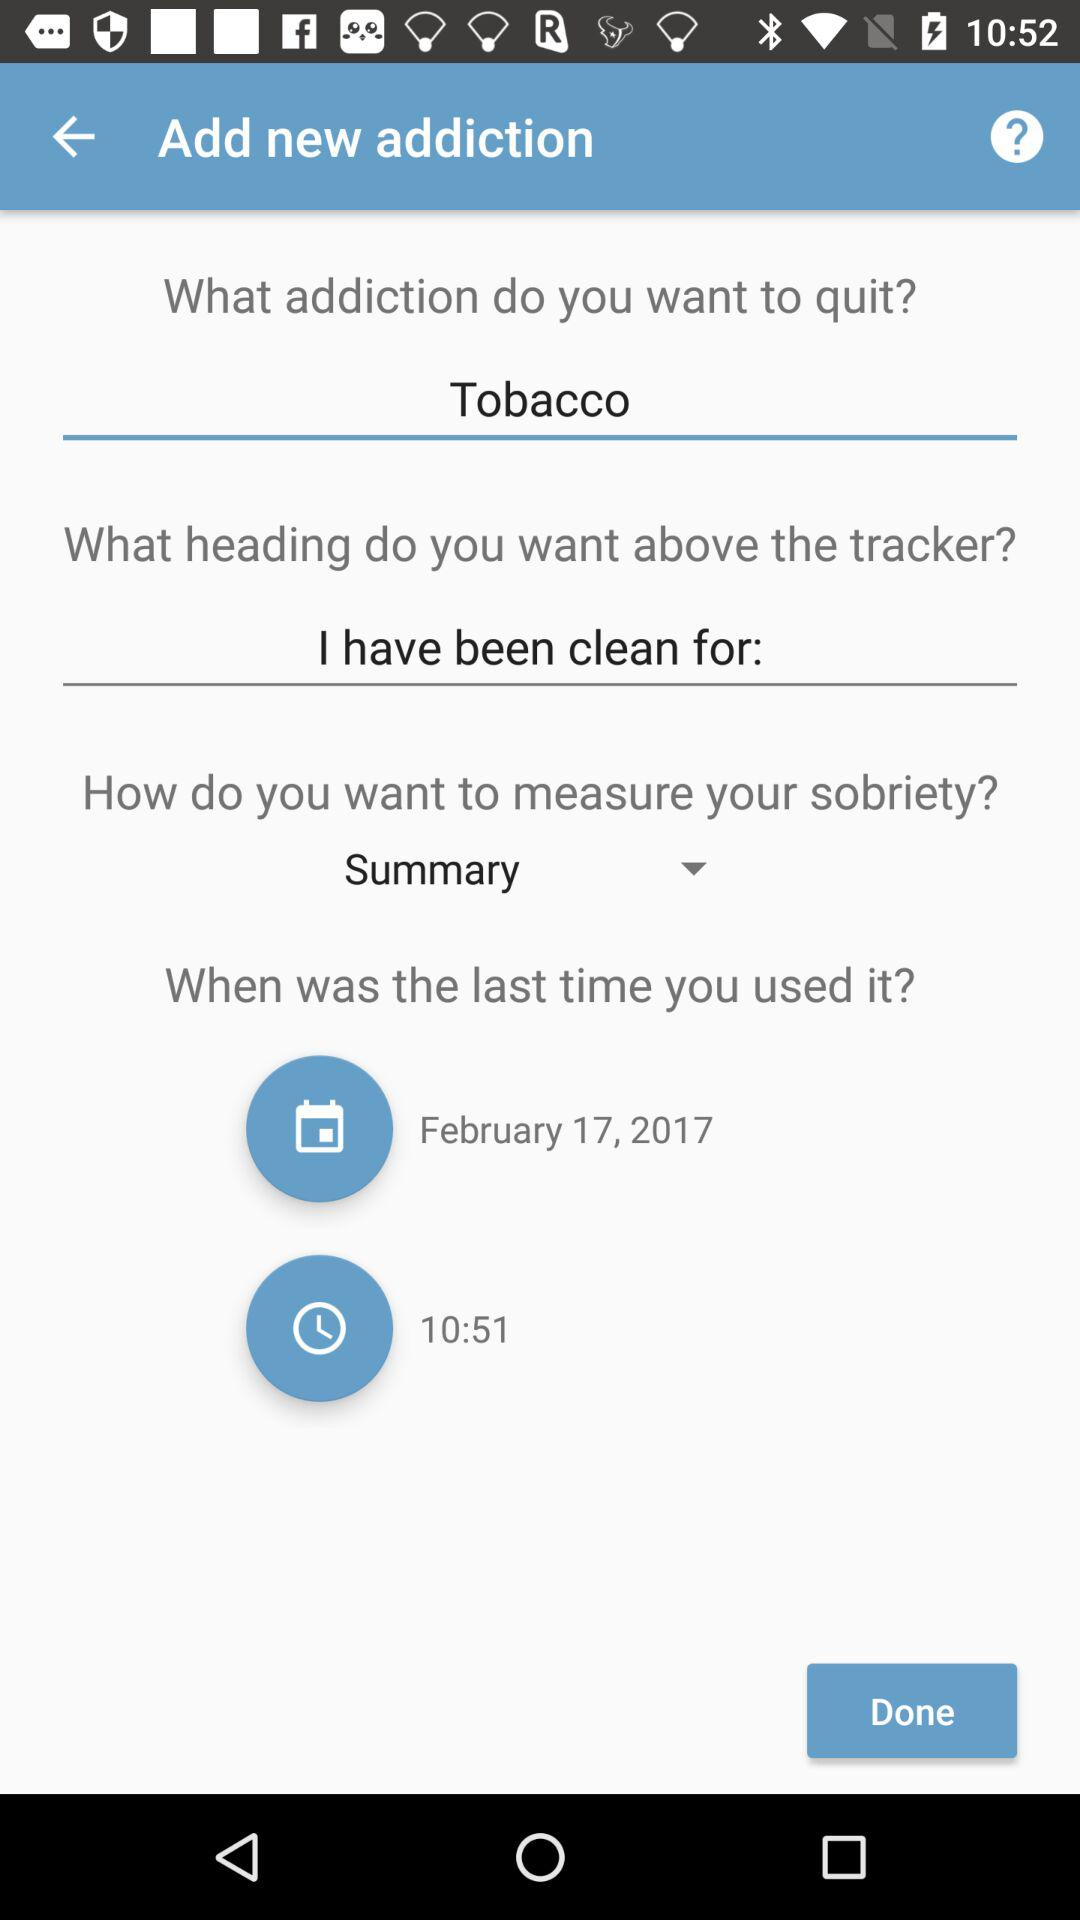What is the entered answer? The entered answers are "Tobacco" and "I have been clean for:". 